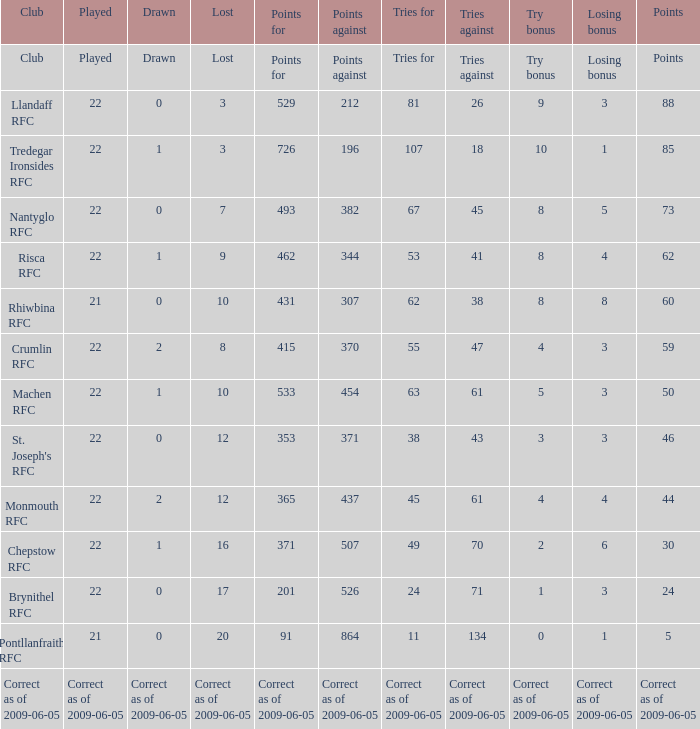If 371 points were scored against, what is the deadlock? 0.0. 